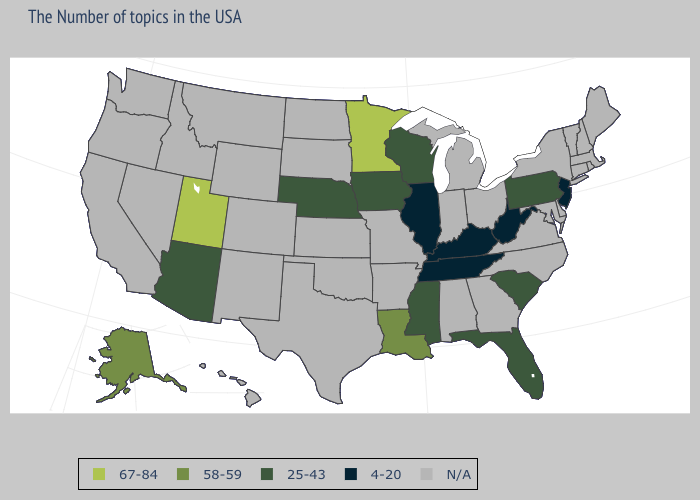What is the value of West Virginia?
Write a very short answer. 4-20. What is the value of Wyoming?
Answer briefly. N/A. Name the states that have a value in the range 67-84?
Keep it brief. Minnesota, Utah. Name the states that have a value in the range N/A?
Give a very brief answer. Maine, Massachusetts, Rhode Island, New Hampshire, Vermont, Connecticut, New York, Delaware, Maryland, Virginia, North Carolina, Ohio, Georgia, Michigan, Indiana, Alabama, Missouri, Arkansas, Kansas, Oklahoma, Texas, South Dakota, North Dakota, Wyoming, Colorado, New Mexico, Montana, Idaho, Nevada, California, Washington, Oregon, Hawaii. Name the states that have a value in the range 67-84?
Be succinct. Minnesota, Utah. Name the states that have a value in the range 58-59?
Be succinct. Louisiana, Alaska. Does Utah have the highest value in the USA?
Quick response, please. Yes. Does Florida have the lowest value in the South?
Write a very short answer. No. What is the value of Michigan?
Be succinct. N/A. What is the value of Oklahoma?
Concise answer only. N/A. Name the states that have a value in the range 58-59?
Short answer required. Louisiana, Alaska. What is the value of Connecticut?
Quick response, please. N/A. Which states have the lowest value in the USA?
Answer briefly. New Jersey, West Virginia, Kentucky, Tennessee, Illinois. 